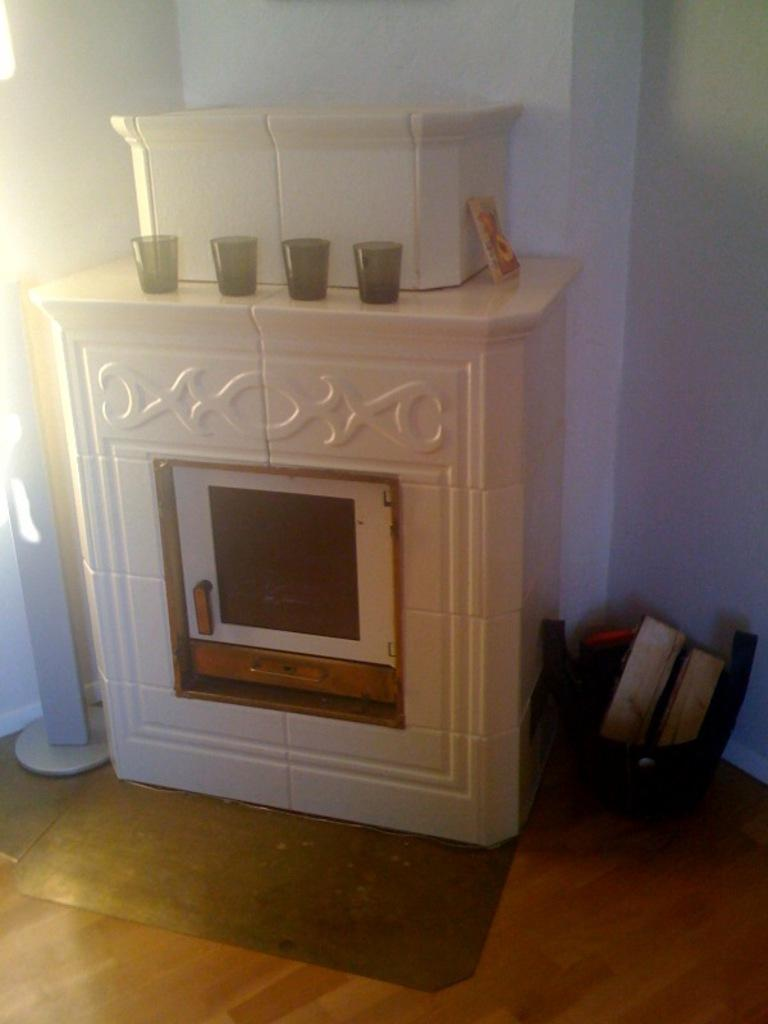What is the main feature in the image? There is a hearth in the image. What objects are placed on the hearth? There are glasses on the hearth. What can be found near the hearth? There is a basket with books near the hearth. What is visible in the background of the image? There is a wall in the background of the image. What type of protest is taking place in the image? There is no protest present in the image; it features a hearth with glasses and a basket with books near a wall. 